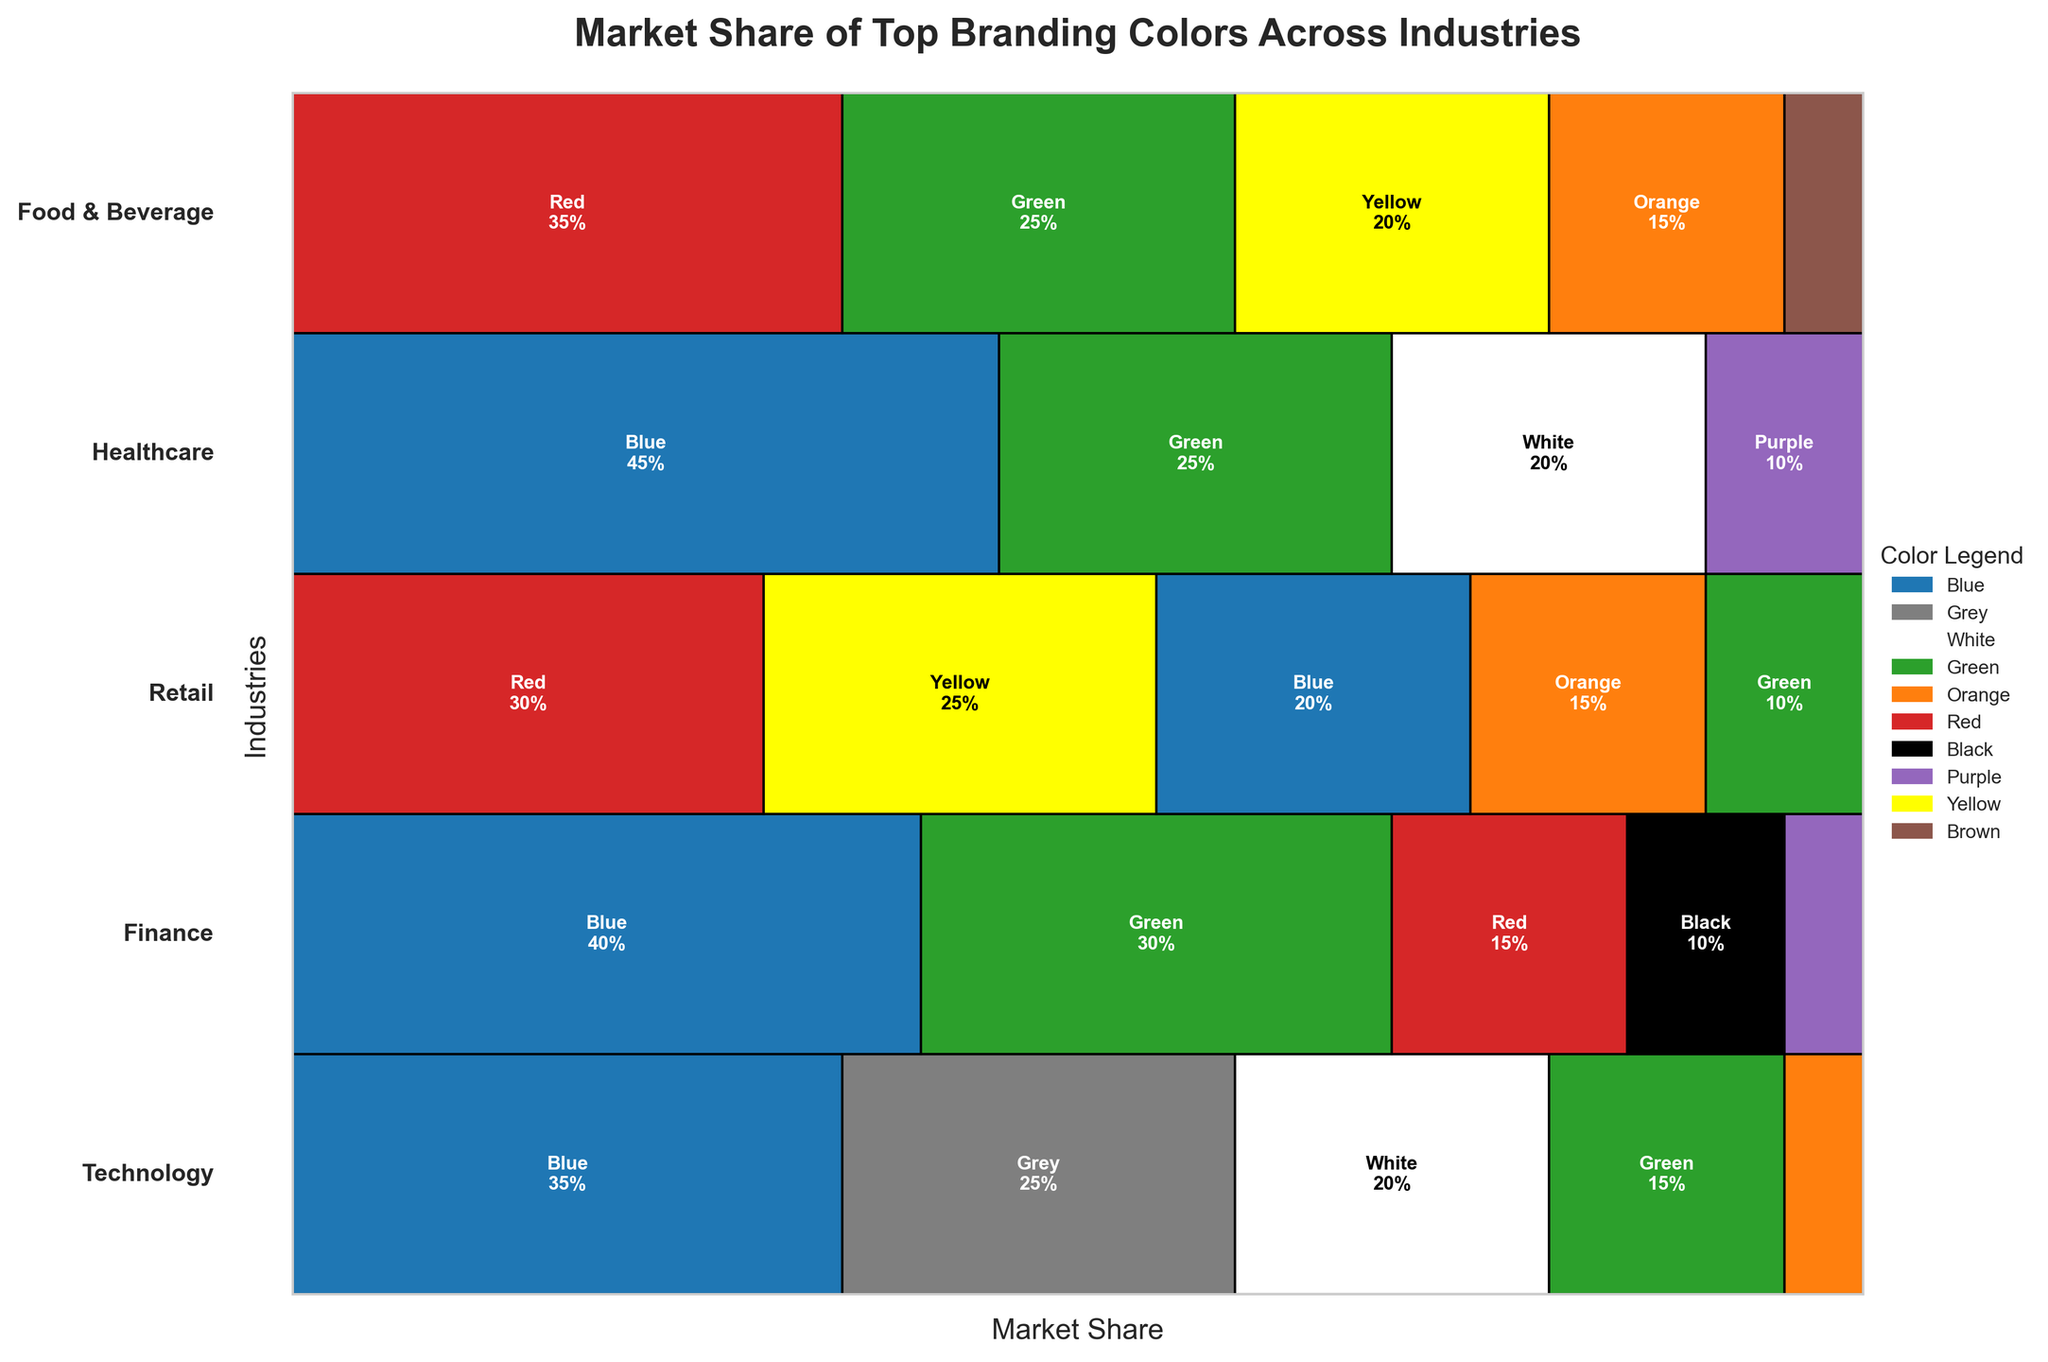Which industry has the highest market share for Blue? The mosaic plot shows various sections representing different industries and colors. By looking at the sections for Blue, it's evident that Healthcare has the largest portion.
Answer: Healthcare What is the total market share of Red across all industries? To find the total market share of Red, add up the values from each industry section: Retail (30), Finance (15), and Food & Beverage (35). 30 + 15 + 35 = 80.
Answer: 80 Which two industries have the same number of branding colors? By counting the number of distinct color sections within each industry, both Technology and Food & Beverage have 5 colors each.
Answer: Technology and Food & Beverage How does the market share of Green in Finance compare to Green in Retail? By examining the sections for Green, the plot shows that Finance has 30% while Retail has 10%. Therefore, Green in Finance is larger compared to Retail.
Answer: Finance has a higher share What is the combined market share of Green and Blue in Technology? Locate the Green and Blue sections in Technology and sum their shares: Green (15) + Blue (35) = 50.
Answer: 50 Which industry uses White more prominently? The mosaic plot shows that both Technology and Healthcare use White, but Healthcare has a larger segment for White at 20%.
Answer: Healthcare How many colors does the Retail industry use, and what are they? By counting the distinct sections in Retail, it uses 5 colors: Red, Yellow, Blue, Orange, and Green.
Answer: 5 colors: Red, Yellow, Blue, Orange, Green What industry has Orange as its smallest section, and what is the share? In Technology, Orange is visible but has the smallest section with a market share of 5%.
Answer: Technology, 5% Compare the largest color sections in Healthcare and Retail. The largest section in Healthcare is Blue at 45%, while in Retail, it is Red at 30%.
Answer: Healthcare: Blue, Retail: Red Which industry shows the most diversity in branding colors, and why? The industry with the highest number of color sections suggests more diversity. Both Technology and Food & Beverage show 5 colors, indicating high diversity.
Answer: Technology and Food & Beverage 